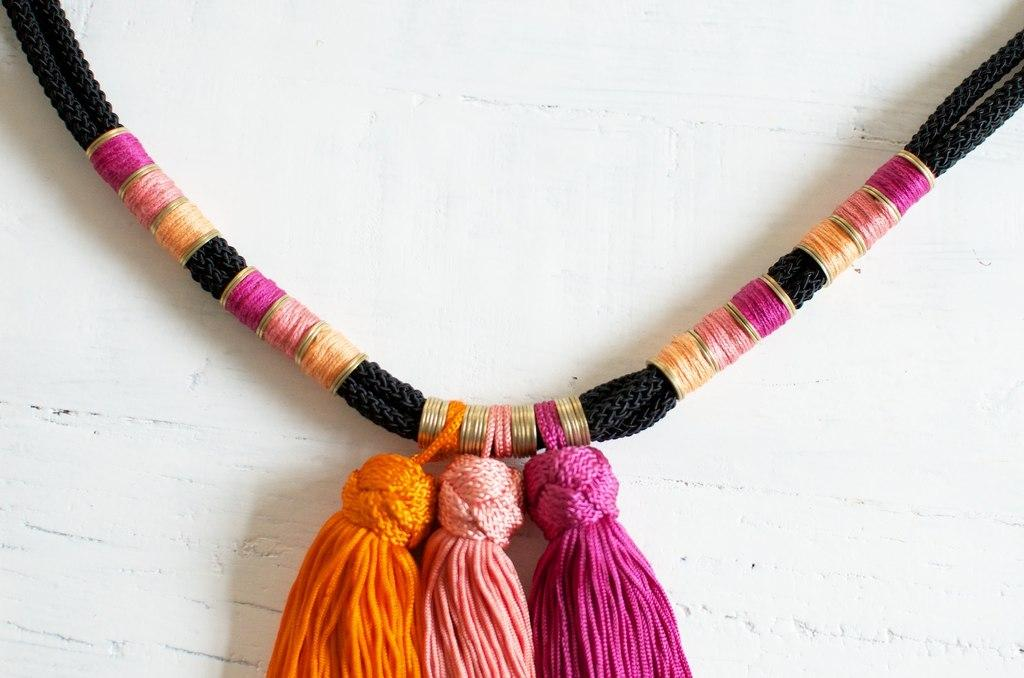What type of necklace is featured in the image? There is a black thread necklace in the image. What is attached to the necklace? The necklace has woolen hangings. What color is the background of the image? The background of the image is white. Can you see any grass in the image? A: There is no grass present in the image; the background is white. 